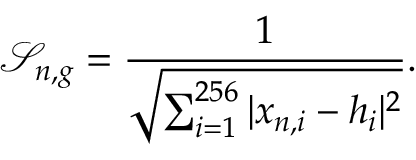Convert formula to latex. <formula><loc_0><loc_0><loc_500><loc_500>\mathcal { S } _ { n , g } = \frac { 1 } { \sqrt { \sum _ { i = 1 } ^ { 2 5 6 } | x _ { n , i } - h _ { i } | ^ { 2 } } } .</formula> 